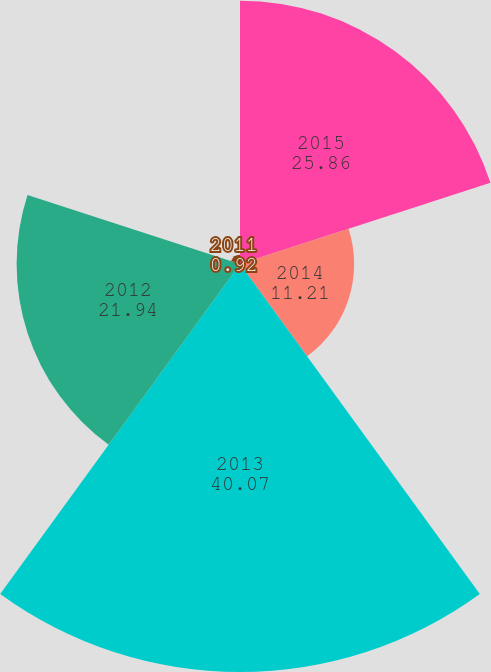Convert chart. <chart><loc_0><loc_0><loc_500><loc_500><pie_chart><fcel>2015<fcel>2014<fcel>2013<fcel>2012<fcel>2011<nl><fcel>25.86%<fcel>11.21%<fcel>40.07%<fcel>21.94%<fcel>0.92%<nl></chart> 